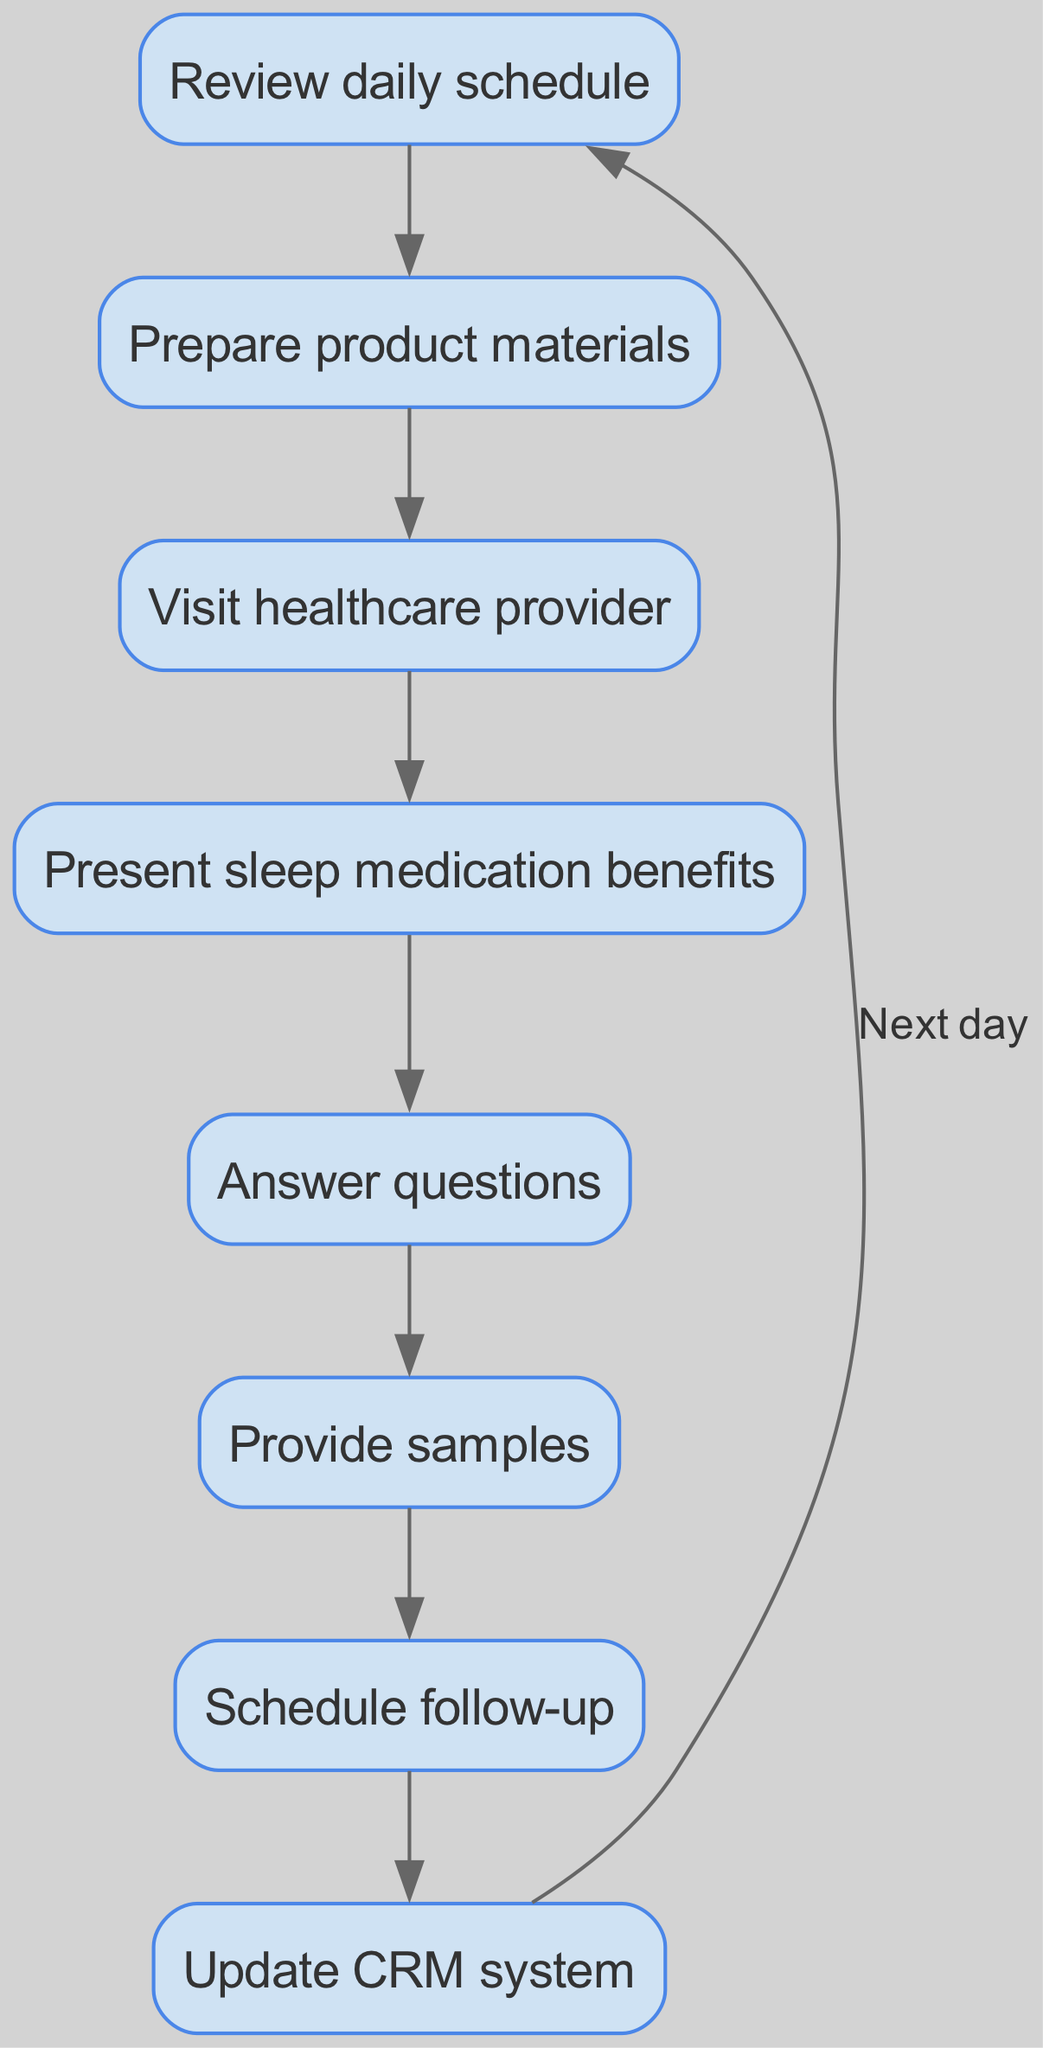What is the first step in the workflow? The first step is to "Review daily schedule," as indicated by the first node in the diagram.
Answer: Review daily schedule How many nodes are there in total? There are eight nodes in the diagram, as listed in the node data.
Answer: Eight What is the last action before updating the CRM system? The last action before updating the CRM system is "Schedule follow-up," which flows into the update step.
Answer: Schedule follow-up Which two nodes are directly connected after presenting the medication benefits? After presenting the medication benefits, the directly connected nodes are "Present sleep medication benefits" and "Answer questions."
Answer: Answer questions What action follows providing samples? The action that follows providing samples is "Schedule follow-up," based on the flow from the samples node to the follow-up node.
Answer: Schedule follow-up How does the workflow cycle back to the starting point? The workflow cycles back to the starting point through the edge connecting "Update CRM system" to "Review daily schedule," indicating the end of one day and the beginning of the next.
Answer: Through updating the CRM system What is the relationship between answering questions and providing samples? The relationship is that "Answer questions" flows into "Provide samples," indicating that answering questions is a prerequisite for providing samples.
Answer: Answer questions How many edges are there between the nodes? There are seven edges connecting the nodes as represented in the edges data.
Answer: Seven 